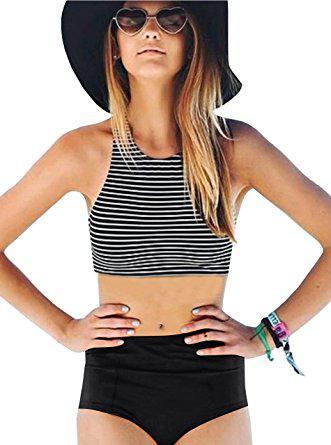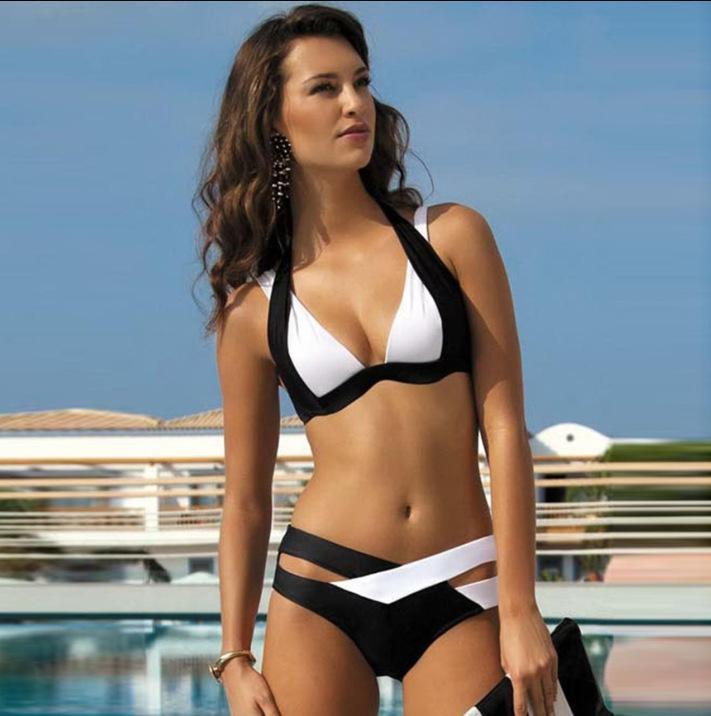The first image is the image on the left, the second image is the image on the right. Evaluate the accuracy of this statement regarding the images: "There is a woman wearing a hat.". Is it true? Answer yes or no. Yes. 